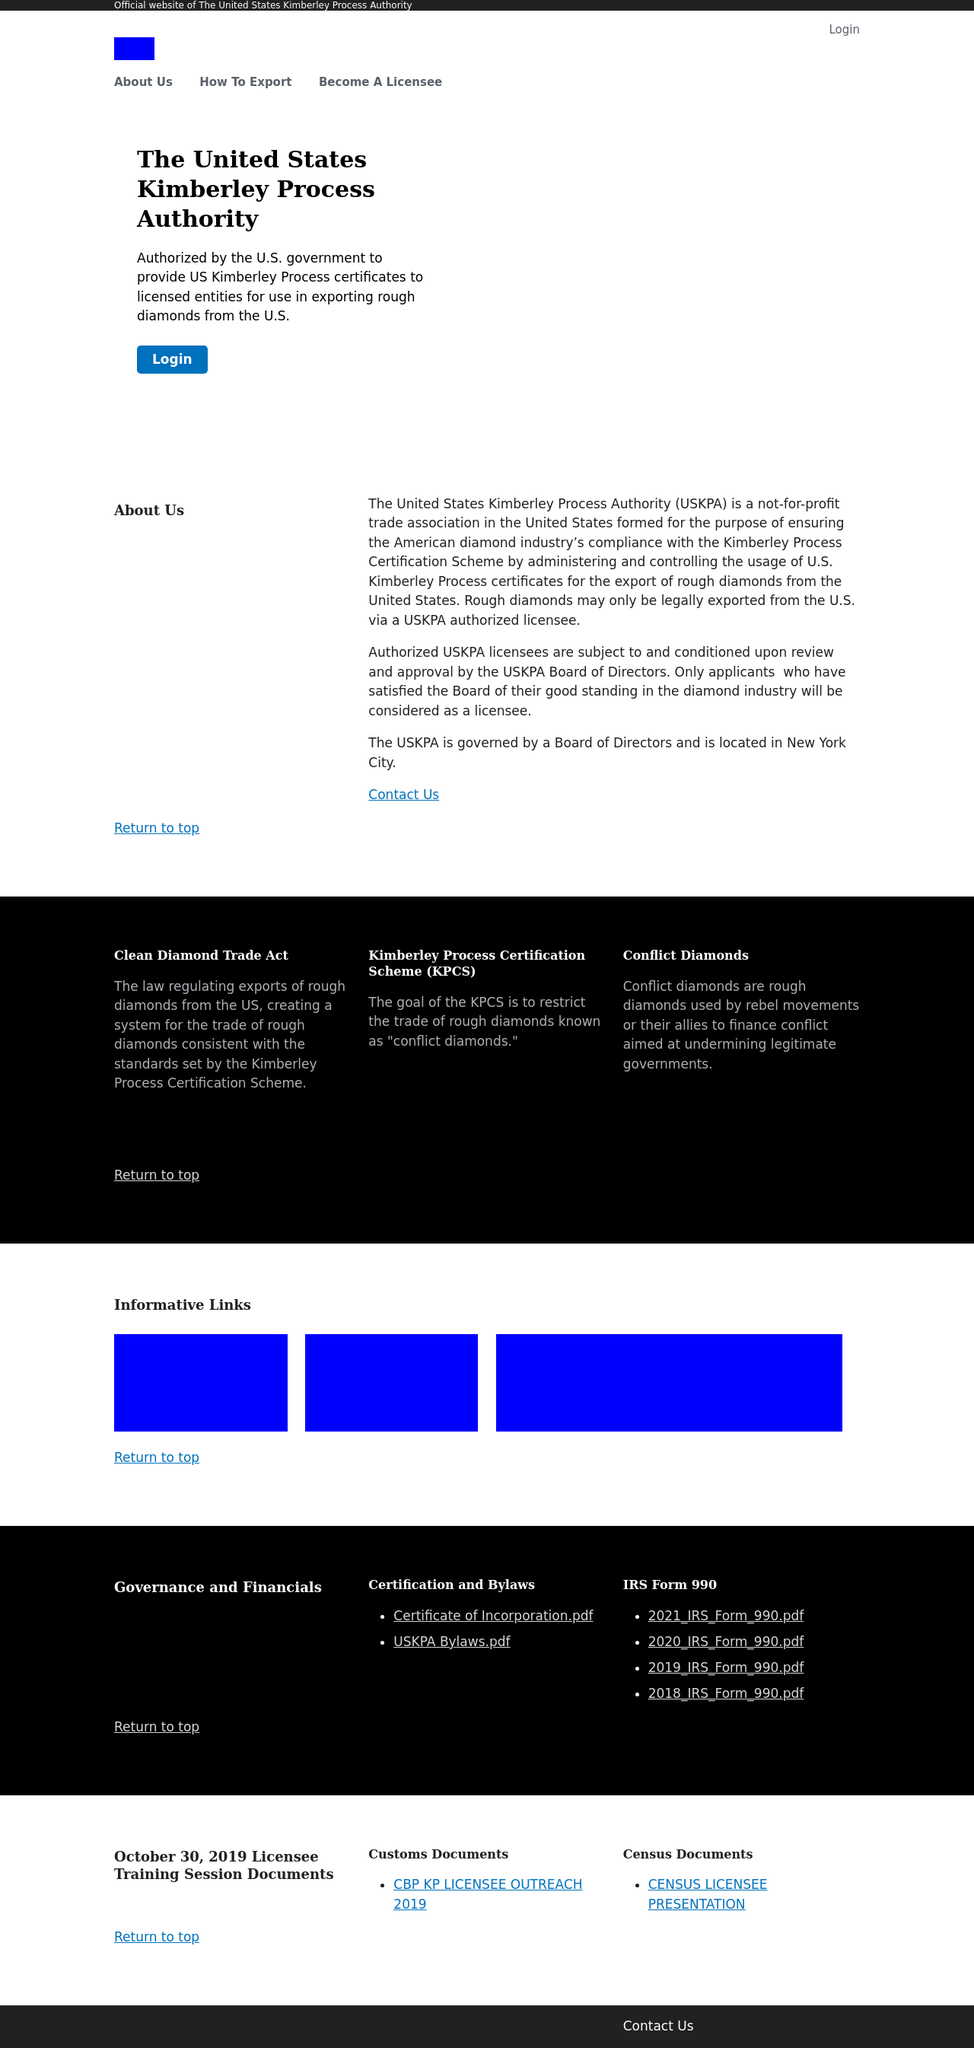How can someone contact the USKPA for more information as shown on the website? To contact the USKPA for further information, one would usually look for contact details on the site. This particular image provides a 'Contact Us' link, suggesting that additional contact information, such as an email address or phone number, might be available after following that link.  What information can I find in the 'Informative Links' section of this website? The 'Informative Links' section likely contains hyperlinks to external resources or partners relevant to the USKPA's operations. Typically, this would include links to the Kimberley Process, associated government agencies, and other entities involved in the diamond trade. 